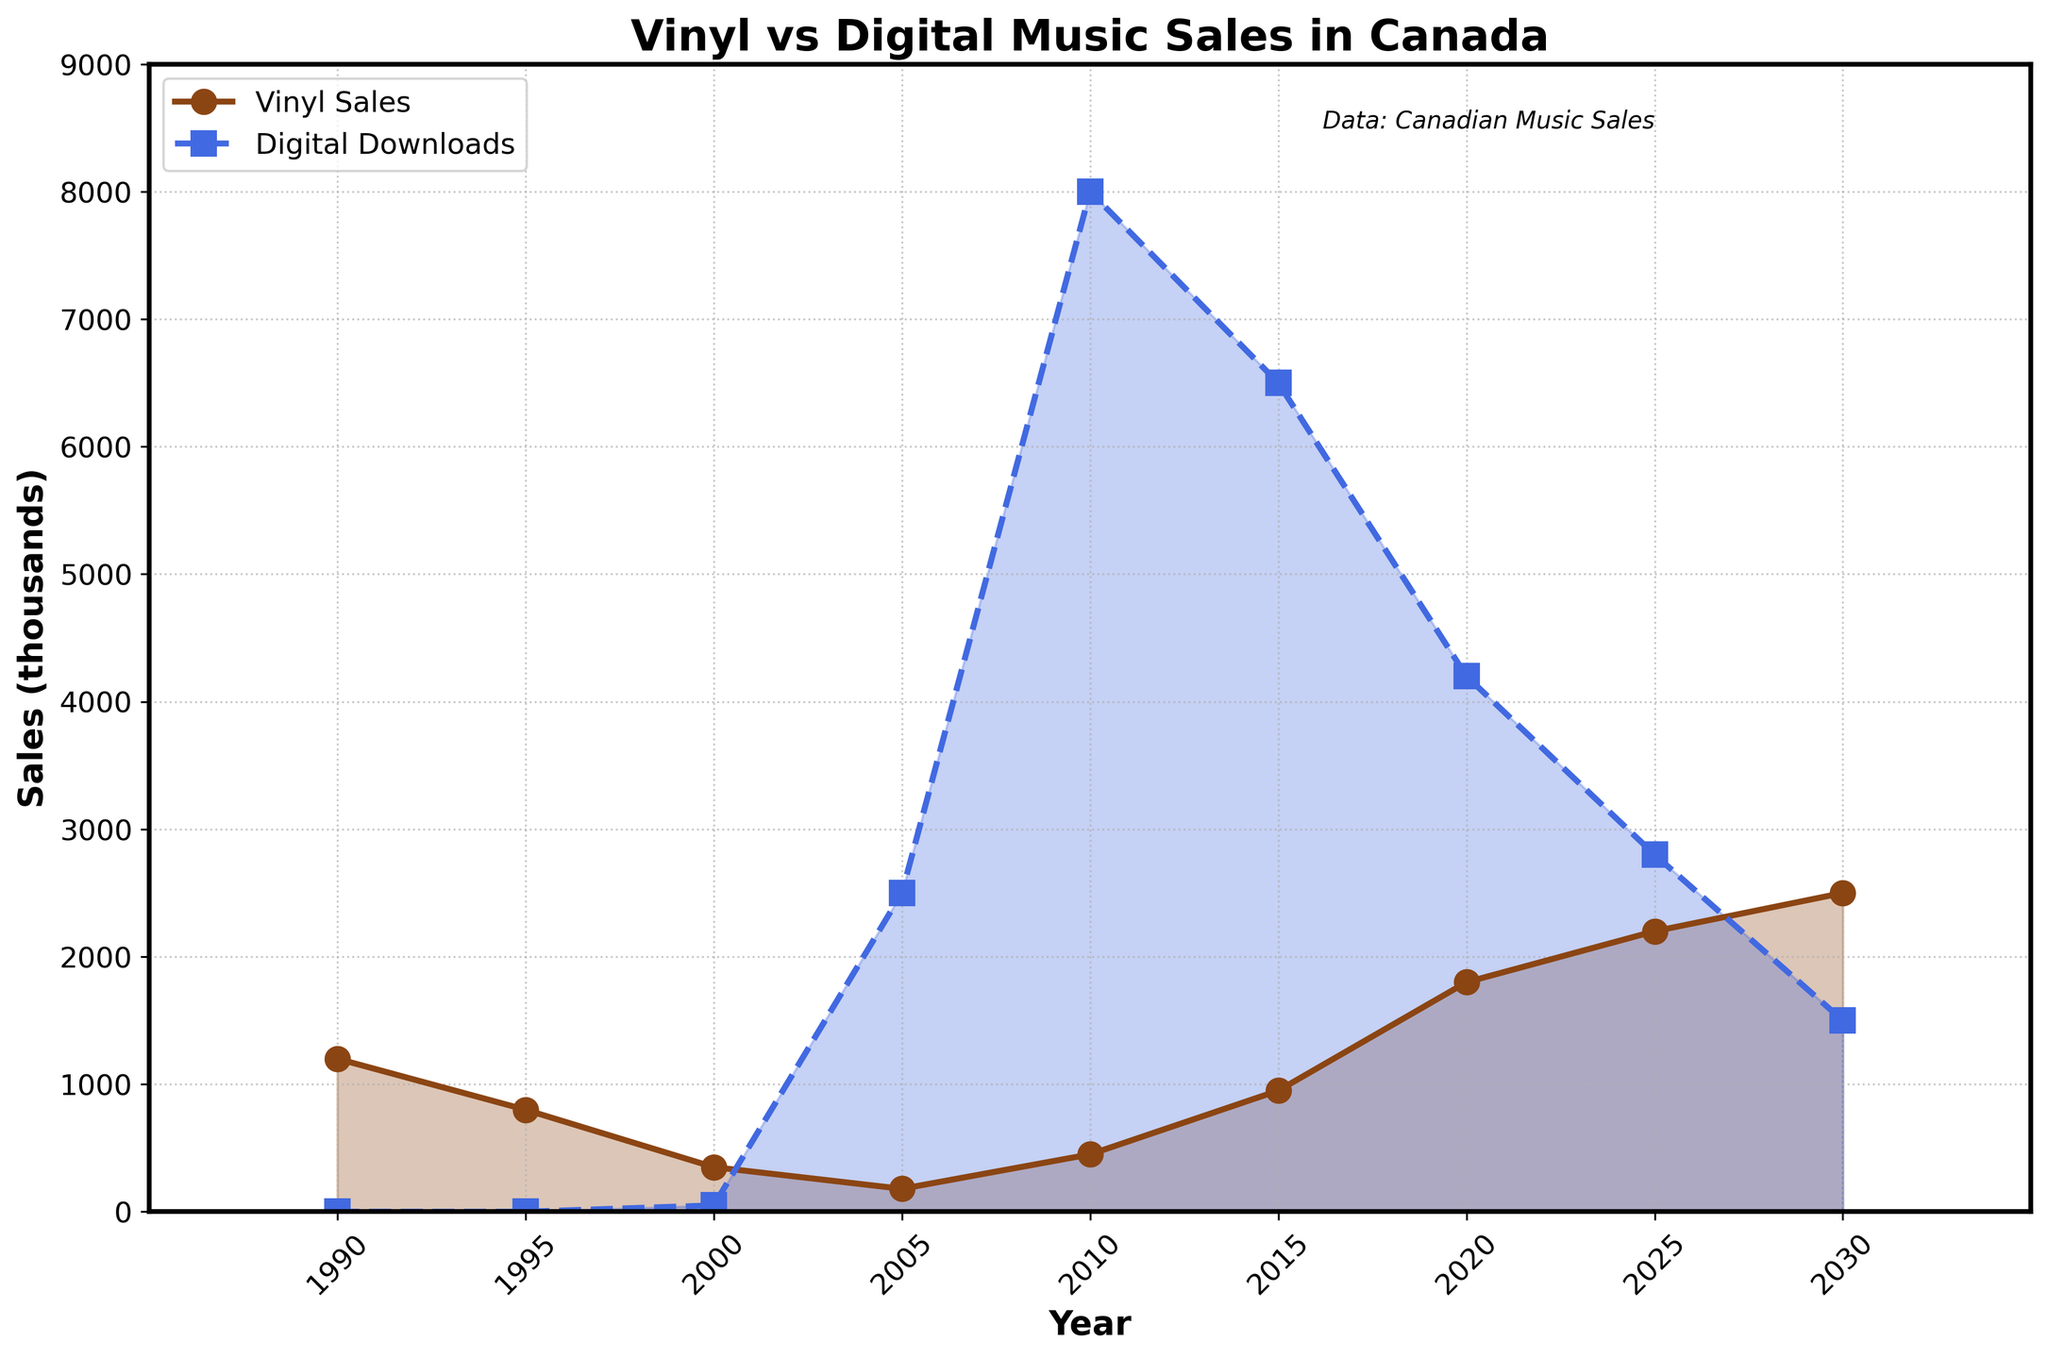What is the general trend of vinyl sales from 1990 to 2030? Vinyl sales initially decrease from 1200 thousand in 1990 to 350 thousand in 2000, then they consistently increase, reaching 2500 thousand by 2030.
Answer: Increasing How did digital downloads change between 2005 and 2015? Digital downloads increased from 2500 thousand in 2005 to 8000 thousand in 2010, then decreased to 6500 thousand by 2015.
Answer: Increased then decreased Which year has the highest figure for digital downloads? The highest figure for digital downloads is in 2010, with 8000 thousand downloads.
Answer: 2010 In 2025, which type of sales was higher: vinyl sales or digital downloads? In 2025, vinyl sales are 2200 thousand, higher than digital downloads at 2800 thousand.
Answer: Digital downloads How did the gap between vinyl sales and digital downloads change from 2000 to 2010? In 2000, digital downloads were 50 thousand and vinyl sales were 350 thousand, a gap of 300 thousand. By 2010, digital downloads were 8000 thousand and vinyl sales were 450 thousand, a gap of 7550 thousand. The gap increased.
Answer: Increased What was the combined total of vinyl sales and digital downloads in 2030? In 2030, vinyl sales are 2500 thousand, and digital downloads are 1500 thousand. The combined total is 2500 + 1500 = 4000 thousand.
Answer: 4000 thousand When do vinyl sales start surpassing digital downloads? Vinyl sales surpass digital downloads in 2025, with 2200 thousand vinyl sales compared to 2800 thousand digital downloads.
Answer: 2025 How does the slope of the vinyl sales line from 2015 to 2020 compare to the slope of the digital downloads line for the same period? Vinyl sales rise from 950 thousand in 2015 to 1800 thousand in 2020, while digital downloads fall from 6500 thousand to 4200 thousand in the same period. The slope of the vinyl sales is positive, while the slope for digital downloads is negative.
Answer: Positive for vinyl, negative for digital Overall, which type of sales experienced a sharper decline between 2015 and 2030? Digital downloads declined from 6500 thousand in 2015 to 1500 thousand in 2030, a difference of 5000 thousand. Vinyl sales increased during this period, so digital downloads experienced a sharper decline.
Answer: Digital downloads What is the visual difference between the lines representing vinyl sales and digital downloads? The line for vinyl sales is solid with circle markers, while the line for digital downloads is dashed with square markers. The vinyl line is brown, and the digital line is blue.
Answer: Different line styles and colors 